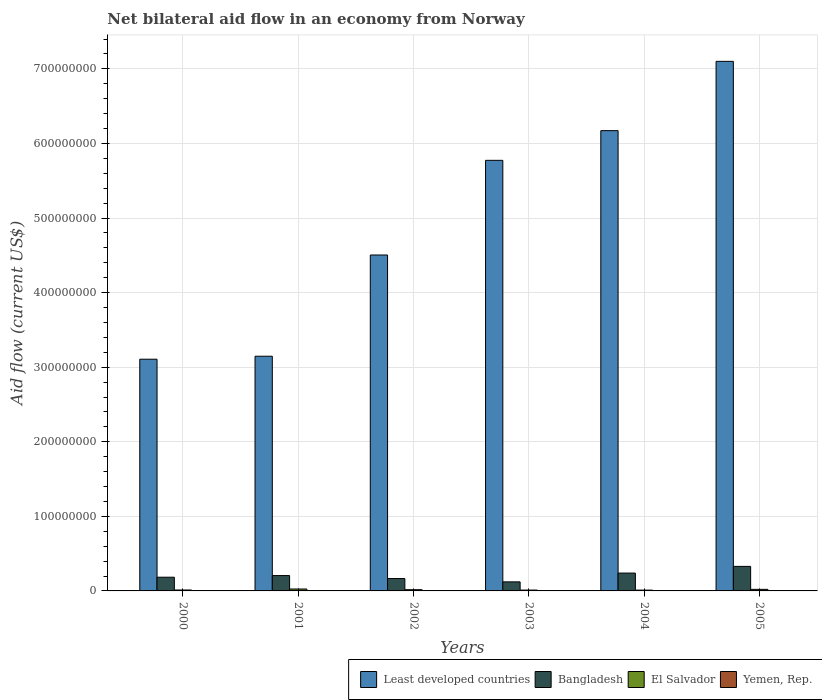Are the number of bars per tick equal to the number of legend labels?
Ensure brevity in your answer.  Yes. How many bars are there on the 3rd tick from the left?
Keep it short and to the point. 4. What is the label of the 3rd group of bars from the left?
Your answer should be compact. 2002. What is the net bilateral aid flow in Bangladesh in 2003?
Ensure brevity in your answer.  1.22e+07. Across all years, what is the maximum net bilateral aid flow in El Salvador?
Your answer should be compact. 2.57e+06. Across all years, what is the minimum net bilateral aid flow in Least developed countries?
Keep it short and to the point. 3.11e+08. What is the total net bilateral aid flow in Yemen, Rep. in the graph?
Provide a succinct answer. 1.70e+06. What is the difference between the net bilateral aid flow in Yemen, Rep. in 2000 and that in 2002?
Give a very brief answer. -2.40e+05. What is the difference between the net bilateral aid flow in El Salvador in 2000 and the net bilateral aid flow in Bangladesh in 2005?
Give a very brief answer. -3.17e+07. What is the average net bilateral aid flow in Least developed countries per year?
Keep it short and to the point. 4.97e+08. In the year 2004, what is the difference between the net bilateral aid flow in Least developed countries and net bilateral aid flow in Yemen, Rep.?
Ensure brevity in your answer.  6.17e+08. In how many years, is the net bilateral aid flow in Bangladesh greater than 360000000 US$?
Make the answer very short. 0. What is the ratio of the net bilateral aid flow in Least developed countries in 2004 to that in 2005?
Your answer should be very brief. 0.87. What is the difference between the highest and the second highest net bilateral aid flow in Least developed countries?
Ensure brevity in your answer.  9.29e+07. What is the difference between the highest and the lowest net bilateral aid flow in Least developed countries?
Keep it short and to the point. 3.99e+08. In how many years, is the net bilateral aid flow in El Salvador greater than the average net bilateral aid flow in El Salvador taken over all years?
Keep it short and to the point. 3. Is the sum of the net bilateral aid flow in El Salvador in 2001 and 2005 greater than the maximum net bilateral aid flow in Bangladesh across all years?
Offer a very short reply. No. Is it the case that in every year, the sum of the net bilateral aid flow in Least developed countries and net bilateral aid flow in Yemen, Rep. is greater than the sum of net bilateral aid flow in Bangladesh and net bilateral aid flow in El Salvador?
Offer a terse response. Yes. What does the 4th bar from the left in 2002 represents?
Give a very brief answer. Yemen, Rep. What does the 1st bar from the right in 2004 represents?
Ensure brevity in your answer.  Yemen, Rep. Is it the case that in every year, the sum of the net bilateral aid flow in El Salvador and net bilateral aid flow in Least developed countries is greater than the net bilateral aid flow in Bangladesh?
Your response must be concise. Yes. How many bars are there?
Offer a terse response. 24. How many years are there in the graph?
Offer a terse response. 6. Does the graph contain any zero values?
Provide a succinct answer. No. Where does the legend appear in the graph?
Provide a short and direct response. Bottom right. What is the title of the graph?
Give a very brief answer. Net bilateral aid flow in an economy from Norway. Does "Low income" appear as one of the legend labels in the graph?
Your answer should be very brief. No. What is the Aid flow (current US$) of Least developed countries in 2000?
Offer a terse response. 3.11e+08. What is the Aid flow (current US$) in Bangladesh in 2000?
Ensure brevity in your answer.  1.84e+07. What is the Aid flow (current US$) of El Salvador in 2000?
Keep it short and to the point. 1.24e+06. What is the Aid flow (current US$) in Least developed countries in 2001?
Offer a terse response. 3.15e+08. What is the Aid flow (current US$) in Bangladesh in 2001?
Your answer should be very brief. 2.06e+07. What is the Aid flow (current US$) in El Salvador in 2001?
Your answer should be very brief. 2.57e+06. What is the Aid flow (current US$) in Yemen, Rep. in 2001?
Your answer should be very brief. 5.00e+04. What is the Aid flow (current US$) of Least developed countries in 2002?
Ensure brevity in your answer.  4.50e+08. What is the Aid flow (current US$) in Bangladesh in 2002?
Provide a short and direct response. 1.66e+07. What is the Aid flow (current US$) of El Salvador in 2002?
Offer a very short reply. 1.67e+06. What is the Aid flow (current US$) in Yemen, Rep. in 2002?
Provide a succinct answer. 3.50e+05. What is the Aid flow (current US$) of Least developed countries in 2003?
Give a very brief answer. 5.77e+08. What is the Aid flow (current US$) in Bangladesh in 2003?
Provide a succinct answer. 1.22e+07. What is the Aid flow (current US$) of El Salvador in 2003?
Ensure brevity in your answer.  1.14e+06. What is the Aid flow (current US$) of Yemen, Rep. in 2003?
Offer a terse response. 3.10e+05. What is the Aid flow (current US$) in Least developed countries in 2004?
Keep it short and to the point. 6.17e+08. What is the Aid flow (current US$) of Bangladesh in 2004?
Your answer should be compact. 2.39e+07. What is the Aid flow (current US$) in El Salvador in 2004?
Offer a terse response. 1.08e+06. What is the Aid flow (current US$) in Least developed countries in 2005?
Offer a terse response. 7.10e+08. What is the Aid flow (current US$) of Bangladesh in 2005?
Offer a very short reply. 3.29e+07. What is the Aid flow (current US$) of El Salvador in 2005?
Provide a short and direct response. 2.11e+06. Across all years, what is the maximum Aid flow (current US$) in Least developed countries?
Provide a short and direct response. 7.10e+08. Across all years, what is the maximum Aid flow (current US$) of Bangladesh?
Provide a short and direct response. 3.29e+07. Across all years, what is the maximum Aid flow (current US$) in El Salvador?
Your answer should be compact. 2.57e+06. Across all years, what is the maximum Aid flow (current US$) in Yemen, Rep.?
Your response must be concise. 4.50e+05. Across all years, what is the minimum Aid flow (current US$) in Least developed countries?
Keep it short and to the point. 3.11e+08. Across all years, what is the minimum Aid flow (current US$) in Bangladesh?
Ensure brevity in your answer.  1.22e+07. Across all years, what is the minimum Aid flow (current US$) in El Salvador?
Your answer should be compact. 1.08e+06. What is the total Aid flow (current US$) of Least developed countries in the graph?
Your answer should be compact. 2.98e+09. What is the total Aid flow (current US$) of Bangladesh in the graph?
Provide a succinct answer. 1.25e+08. What is the total Aid flow (current US$) of El Salvador in the graph?
Your answer should be compact. 9.81e+06. What is the total Aid flow (current US$) of Yemen, Rep. in the graph?
Ensure brevity in your answer.  1.70e+06. What is the difference between the Aid flow (current US$) of Bangladesh in 2000 and that in 2001?
Make the answer very short. -2.20e+06. What is the difference between the Aid flow (current US$) of El Salvador in 2000 and that in 2001?
Provide a succinct answer. -1.33e+06. What is the difference between the Aid flow (current US$) of Yemen, Rep. in 2000 and that in 2001?
Provide a succinct answer. 6.00e+04. What is the difference between the Aid flow (current US$) in Least developed countries in 2000 and that in 2002?
Your response must be concise. -1.40e+08. What is the difference between the Aid flow (current US$) of Bangladesh in 2000 and that in 2002?
Make the answer very short. 1.77e+06. What is the difference between the Aid flow (current US$) in El Salvador in 2000 and that in 2002?
Give a very brief answer. -4.30e+05. What is the difference between the Aid flow (current US$) in Yemen, Rep. in 2000 and that in 2002?
Give a very brief answer. -2.40e+05. What is the difference between the Aid flow (current US$) of Least developed countries in 2000 and that in 2003?
Keep it short and to the point. -2.67e+08. What is the difference between the Aid flow (current US$) of Bangladesh in 2000 and that in 2003?
Offer a terse response. 6.23e+06. What is the difference between the Aid flow (current US$) of El Salvador in 2000 and that in 2003?
Provide a short and direct response. 1.00e+05. What is the difference between the Aid flow (current US$) of Yemen, Rep. in 2000 and that in 2003?
Give a very brief answer. -2.00e+05. What is the difference between the Aid flow (current US$) of Least developed countries in 2000 and that in 2004?
Offer a terse response. -3.06e+08. What is the difference between the Aid flow (current US$) in Bangladesh in 2000 and that in 2004?
Your answer should be compact. -5.56e+06. What is the difference between the Aid flow (current US$) of Yemen, Rep. in 2000 and that in 2004?
Provide a short and direct response. -3.20e+05. What is the difference between the Aid flow (current US$) of Least developed countries in 2000 and that in 2005?
Provide a short and direct response. -3.99e+08. What is the difference between the Aid flow (current US$) in Bangladesh in 2000 and that in 2005?
Provide a succinct answer. -1.45e+07. What is the difference between the Aid flow (current US$) in El Salvador in 2000 and that in 2005?
Offer a terse response. -8.70e+05. What is the difference between the Aid flow (current US$) in Least developed countries in 2001 and that in 2002?
Make the answer very short. -1.36e+08. What is the difference between the Aid flow (current US$) of Bangladesh in 2001 and that in 2002?
Offer a very short reply. 3.97e+06. What is the difference between the Aid flow (current US$) of El Salvador in 2001 and that in 2002?
Keep it short and to the point. 9.00e+05. What is the difference between the Aid flow (current US$) in Least developed countries in 2001 and that in 2003?
Offer a very short reply. -2.63e+08. What is the difference between the Aid flow (current US$) in Bangladesh in 2001 and that in 2003?
Offer a terse response. 8.43e+06. What is the difference between the Aid flow (current US$) of El Salvador in 2001 and that in 2003?
Give a very brief answer. 1.43e+06. What is the difference between the Aid flow (current US$) of Yemen, Rep. in 2001 and that in 2003?
Give a very brief answer. -2.60e+05. What is the difference between the Aid flow (current US$) in Least developed countries in 2001 and that in 2004?
Ensure brevity in your answer.  -3.02e+08. What is the difference between the Aid flow (current US$) of Bangladesh in 2001 and that in 2004?
Ensure brevity in your answer.  -3.36e+06. What is the difference between the Aid flow (current US$) of El Salvador in 2001 and that in 2004?
Offer a very short reply. 1.49e+06. What is the difference between the Aid flow (current US$) in Yemen, Rep. in 2001 and that in 2004?
Offer a terse response. -3.80e+05. What is the difference between the Aid flow (current US$) of Least developed countries in 2001 and that in 2005?
Your response must be concise. -3.95e+08. What is the difference between the Aid flow (current US$) in Bangladesh in 2001 and that in 2005?
Provide a succinct answer. -1.23e+07. What is the difference between the Aid flow (current US$) in Yemen, Rep. in 2001 and that in 2005?
Your response must be concise. -4.00e+05. What is the difference between the Aid flow (current US$) in Least developed countries in 2002 and that in 2003?
Your response must be concise. -1.27e+08. What is the difference between the Aid flow (current US$) in Bangladesh in 2002 and that in 2003?
Ensure brevity in your answer.  4.46e+06. What is the difference between the Aid flow (current US$) of El Salvador in 2002 and that in 2003?
Keep it short and to the point. 5.30e+05. What is the difference between the Aid flow (current US$) in Least developed countries in 2002 and that in 2004?
Provide a short and direct response. -1.67e+08. What is the difference between the Aid flow (current US$) in Bangladesh in 2002 and that in 2004?
Ensure brevity in your answer.  -7.33e+06. What is the difference between the Aid flow (current US$) of El Salvador in 2002 and that in 2004?
Provide a succinct answer. 5.90e+05. What is the difference between the Aid flow (current US$) of Yemen, Rep. in 2002 and that in 2004?
Keep it short and to the point. -8.00e+04. What is the difference between the Aid flow (current US$) in Least developed countries in 2002 and that in 2005?
Ensure brevity in your answer.  -2.60e+08. What is the difference between the Aid flow (current US$) in Bangladesh in 2002 and that in 2005?
Ensure brevity in your answer.  -1.63e+07. What is the difference between the Aid flow (current US$) in El Salvador in 2002 and that in 2005?
Your answer should be compact. -4.40e+05. What is the difference between the Aid flow (current US$) of Yemen, Rep. in 2002 and that in 2005?
Your answer should be very brief. -1.00e+05. What is the difference between the Aid flow (current US$) in Least developed countries in 2003 and that in 2004?
Provide a short and direct response. -3.98e+07. What is the difference between the Aid flow (current US$) of Bangladesh in 2003 and that in 2004?
Make the answer very short. -1.18e+07. What is the difference between the Aid flow (current US$) of El Salvador in 2003 and that in 2004?
Offer a terse response. 6.00e+04. What is the difference between the Aid flow (current US$) of Least developed countries in 2003 and that in 2005?
Provide a short and direct response. -1.33e+08. What is the difference between the Aid flow (current US$) in Bangladesh in 2003 and that in 2005?
Provide a short and direct response. -2.08e+07. What is the difference between the Aid flow (current US$) of El Salvador in 2003 and that in 2005?
Provide a short and direct response. -9.70e+05. What is the difference between the Aid flow (current US$) of Least developed countries in 2004 and that in 2005?
Your response must be concise. -9.29e+07. What is the difference between the Aid flow (current US$) of Bangladesh in 2004 and that in 2005?
Keep it short and to the point. -8.97e+06. What is the difference between the Aid flow (current US$) in El Salvador in 2004 and that in 2005?
Ensure brevity in your answer.  -1.03e+06. What is the difference between the Aid flow (current US$) in Least developed countries in 2000 and the Aid flow (current US$) in Bangladesh in 2001?
Make the answer very short. 2.90e+08. What is the difference between the Aid flow (current US$) in Least developed countries in 2000 and the Aid flow (current US$) in El Salvador in 2001?
Make the answer very short. 3.08e+08. What is the difference between the Aid flow (current US$) in Least developed countries in 2000 and the Aid flow (current US$) in Yemen, Rep. in 2001?
Your answer should be very brief. 3.11e+08. What is the difference between the Aid flow (current US$) of Bangladesh in 2000 and the Aid flow (current US$) of El Salvador in 2001?
Provide a short and direct response. 1.58e+07. What is the difference between the Aid flow (current US$) of Bangladesh in 2000 and the Aid flow (current US$) of Yemen, Rep. in 2001?
Your response must be concise. 1.83e+07. What is the difference between the Aid flow (current US$) of El Salvador in 2000 and the Aid flow (current US$) of Yemen, Rep. in 2001?
Ensure brevity in your answer.  1.19e+06. What is the difference between the Aid flow (current US$) in Least developed countries in 2000 and the Aid flow (current US$) in Bangladesh in 2002?
Provide a short and direct response. 2.94e+08. What is the difference between the Aid flow (current US$) of Least developed countries in 2000 and the Aid flow (current US$) of El Salvador in 2002?
Offer a terse response. 3.09e+08. What is the difference between the Aid flow (current US$) in Least developed countries in 2000 and the Aid flow (current US$) in Yemen, Rep. in 2002?
Keep it short and to the point. 3.10e+08. What is the difference between the Aid flow (current US$) in Bangladesh in 2000 and the Aid flow (current US$) in El Salvador in 2002?
Provide a succinct answer. 1.67e+07. What is the difference between the Aid flow (current US$) in Bangladesh in 2000 and the Aid flow (current US$) in Yemen, Rep. in 2002?
Offer a terse response. 1.80e+07. What is the difference between the Aid flow (current US$) in El Salvador in 2000 and the Aid flow (current US$) in Yemen, Rep. in 2002?
Your answer should be compact. 8.90e+05. What is the difference between the Aid flow (current US$) of Least developed countries in 2000 and the Aid flow (current US$) of Bangladesh in 2003?
Provide a short and direct response. 2.99e+08. What is the difference between the Aid flow (current US$) in Least developed countries in 2000 and the Aid flow (current US$) in El Salvador in 2003?
Keep it short and to the point. 3.10e+08. What is the difference between the Aid flow (current US$) in Least developed countries in 2000 and the Aid flow (current US$) in Yemen, Rep. in 2003?
Give a very brief answer. 3.10e+08. What is the difference between the Aid flow (current US$) in Bangladesh in 2000 and the Aid flow (current US$) in El Salvador in 2003?
Your answer should be compact. 1.72e+07. What is the difference between the Aid flow (current US$) of Bangladesh in 2000 and the Aid flow (current US$) of Yemen, Rep. in 2003?
Ensure brevity in your answer.  1.81e+07. What is the difference between the Aid flow (current US$) in El Salvador in 2000 and the Aid flow (current US$) in Yemen, Rep. in 2003?
Your answer should be compact. 9.30e+05. What is the difference between the Aid flow (current US$) of Least developed countries in 2000 and the Aid flow (current US$) of Bangladesh in 2004?
Give a very brief answer. 2.87e+08. What is the difference between the Aid flow (current US$) of Least developed countries in 2000 and the Aid flow (current US$) of El Salvador in 2004?
Provide a succinct answer. 3.10e+08. What is the difference between the Aid flow (current US$) of Least developed countries in 2000 and the Aid flow (current US$) of Yemen, Rep. in 2004?
Ensure brevity in your answer.  3.10e+08. What is the difference between the Aid flow (current US$) in Bangladesh in 2000 and the Aid flow (current US$) in El Salvador in 2004?
Provide a short and direct response. 1.73e+07. What is the difference between the Aid flow (current US$) of Bangladesh in 2000 and the Aid flow (current US$) of Yemen, Rep. in 2004?
Offer a terse response. 1.80e+07. What is the difference between the Aid flow (current US$) of El Salvador in 2000 and the Aid flow (current US$) of Yemen, Rep. in 2004?
Your response must be concise. 8.10e+05. What is the difference between the Aid flow (current US$) in Least developed countries in 2000 and the Aid flow (current US$) in Bangladesh in 2005?
Make the answer very short. 2.78e+08. What is the difference between the Aid flow (current US$) in Least developed countries in 2000 and the Aid flow (current US$) in El Salvador in 2005?
Give a very brief answer. 3.09e+08. What is the difference between the Aid flow (current US$) of Least developed countries in 2000 and the Aid flow (current US$) of Yemen, Rep. in 2005?
Ensure brevity in your answer.  3.10e+08. What is the difference between the Aid flow (current US$) in Bangladesh in 2000 and the Aid flow (current US$) in El Salvador in 2005?
Your response must be concise. 1.63e+07. What is the difference between the Aid flow (current US$) in Bangladesh in 2000 and the Aid flow (current US$) in Yemen, Rep. in 2005?
Provide a short and direct response. 1.79e+07. What is the difference between the Aid flow (current US$) of El Salvador in 2000 and the Aid flow (current US$) of Yemen, Rep. in 2005?
Ensure brevity in your answer.  7.90e+05. What is the difference between the Aid flow (current US$) in Least developed countries in 2001 and the Aid flow (current US$) in Bangladesh in 2002?
Ensure brevity in your answer.  2.98e+08. What is the difference between the Aid flow (current US$) in Least developed countries in 2001 and the Aid flow (current US$) in El Salvador in 2002?
Keep it short and to the point. 3.13e+08. What is the difference between the Aid flow (current US$) in Least developed countries in 2001 and the Aid flow (current US$) in Yemen, Rep. in 2002?
Provide a succinct answer. 3.14e+08. What is the difference between the Aid flow (current US$) of Bangladesh in 2001 and the Aid flow (current US$) of El Salvador in 2002?
Your response must be concise. 1.89e+07. What is the difference between the Aid flow (current US$) of Bangladesh in 2001 and the Aid flow (current US$) of Yemen, Rep. in 2002?
Offer a terse response. 2.02e+07. What is the difference between the Aid flow (current US$) of El Salvador in 2001 and the Aid flow (current US$) of Yemen, Rep. in 2002?
Offer a terse response. 2.22e+06. What is the difference between the Aid flow (current US$) of Least developed countries in 2001 and the Aid flow (current US$) of Bangladesh in 2003?
Keep it short and to the point. 3.03e+08. What is the difference between the Aid flow (current US$) of Least developed countries in 2001 and the Aid flow (current US$) of El Salvador in 2003?
Your answer should be compact. 3.14e+08. What is the difference between the Aid flow (current US$) of Least developed countries in 2001 and the Aid flow (current US$) of Yemen, Rep. in 2003?
Keep it short and to the point. 3.14e+08. What is the difference between the Aid flow (current US$) of Bangladesh in 2001 and the Aid flow (current US$) of El Salvador in 2003?
Keep it short and to the point. 1.94e+07. What is the difference between the Aid flow (current US$) of Bangladesh in 2001 and the Aid flow (current US$) of Yemen, Rep. in 2003?
Offer a very short reply. 2.03e+07. What is the difference between the Aid flow (current US$) of El Salvador in 2001 and the Aid flow (current US$) of Yemen, Rep. in 2003?
Your answer should be compact. 2.26e+06. What is the difference between the Aid flow (current US$) of Least developed countries in 2001 and the Aid flow (current US$) of Bangladesh in 2004?
Give a very brief answer. 2.91e+08. What is the difference between the Aid flow (current US$) of Least developed countries in 2001 and the Aid flow (current US$) of El Salvador in 2004?
Ensure brevity in your answer.  3.14e+08. What is the difference between the Aid flow (current US$) in Least developed countries in 2001 and the Aid flow (current US$) in Yemen, Rep. in 2004?
Give a very brief answer. 3.14e+08. What is the difference between the Aid flow (current US$) of Bangladesh in 2001 and the Aid flow (current US$) of El Salvador in 2004?
Make the answer very short. 1.95e+07. What is the difference between the Aid flow (current US$) of Bangladesh in 2001 and the Aid flow (current US$) of Yemen, Rep. in 2004?
Make the answer very short. 2.02e+07. What is the difference between the Aid flow (current US$) in El Salvador in 2001 and the Aid flow (current US$) in Yemen, Rep. in 2004?
Your answer should be very brief. 2.14e+06. What is the difference between the Aid flow (current US$) in Least developed countries in 2001 and the Aid flow (current US$) in Bangladesh in 2005?
Your answer should be compact. 2.82e+08. What is the difference between the Aid flow (current US$) in Least developed countries in 2001 and the Aid flow (current US$) in El Salvador in 2005?
Offer a terse response. 3.13e+08. What is the difference between the Aid flow (current US$) in Least developed countries in 2001 and the Aid flow (current US$) in Yemen, Rep. in 2005?
Make the answer very short. 3.14e+08. What is the difference between the Aid flow (current US$) of Bangladesh in 2001 and the Aid flow (current US$) of El Salvador in 2005?
Offer a terse response. 1.85e+07. What is the difference between the Aid flow (current US$) in Bangladesh in 2001 and the Aid flow (current US$) in Yemen, Rep. in 2005?
Make the answer very short. 2.01e+07. What is the difference between the Aid flow (current US$) of El Salvador in 2001 and the Aid flow (current US$) of Yemen, Rep. in 2005?
Your response must be concise. 2.12e+06. What is the difference between the Aid flow (current US$) in Least developed countries in 2002 and the Aid flow (current US$) in Bangladesh in 2003?
Keep it short and to the point. 4.38e+08. What is the difference between the Aid flow (current US$) in Least developed countries in 2002 and the Aid flow (current US$) in El Salvador in 2003?
Your response must be concise. 4.49e+08. What is the difference between the Aid flow (current US$) of Least developed countries in 2002 and the Aid flow (current US$) of Yemen, Rep. in 2003?
Offer a terse response. 4.50e+08. What is the difference between the Aid flow (current US$) in Bangladesh in 2002 and the Aid flow (current US$) in El Salvador in 2003?
Ensure brevity in your answer.  1.55e+07. What is the difference between the Aid flow (current US$) of Bangladesh in 2002 and the Aid flow (current US$) of Yemen, Rep. in 2003?
Make the answer very short. 1.63e+07. What is the difference between the Aid flow (current US$) of El Salvador in 2002 and the Aid flow (current US$) of Yemen, Rep. in 2003?
Make the answer very short. 1.36e+06. What is the difference between the Aid flow (current US$) of Least developed countries in 2002 and the Aid flow (current US$) of Bangladesh in 2004?
Provide a succinct answer. 4.27e+08. What is the difference between the Aid flow (current US$) in Least developed countries in 2002 and the Aid flow (current US$) in El Salvador in 2004?
Your response must be concise. 4.49e+08. What is the difference between the Aid flow (current US$) of Least developed countries in 2002 and the Aid flow (current US$) of Yemen, Rep. in 2004?
Ensure brevity in your answer.  4.50e+08. What is the difference between the Aid flow (current US$) of Bangladesh in 2002 and the Aid flow (current US$) of El Salvador in 2004?
Your answer should be compact. 1.55e+07. What is the difference between the Aid flow (current US$) of Bangladesh in 2002 and the Aid flow (current US$) of Yemen, Rep. in 2004?
Give a very brief answer. 1.62e+07. What is the difference between the Aid flow (current US$) of El Salvador in 2002 and the Aid flow (current US$) of Yemen, Rep. in 2004?
Provide a short and direct response. 1.24e+06. What is the difference between the Aid flow (current US$) of Least developed countries in 2002 and the Aid flow (current US$) of Bangladesh in 2005?
Your response must be concise. 4.18e+08. What is the difference between the Aid flow (current US$) in Least developed countries in 2002 and the Aid flow (current US$) in El Salvador in 2005?
Give a very brief answer. 4.48e+08. What is the difference between the Aid flow (current US$) of Least developed countries in 2002 and the Aid flow (current US$) of Yemen, Rep. in 2005?
Provide a succinct answer. 4.50e+08. What is the difference between the Aid flow (current US$) in Bangladesh in 2002 and the Aid flow (current US$) in El Salvador in 2005?
Give a very brief answer. 1.45e+07. What is the difference between the Aid flow (current US$) in Bangladesh in 2002 and the Aid flow (current US$) in Yemen, Rep. in 2005?
Provide a short and direct response. 1.62e+07. What is the difference between the Aid flow (current US$) of El Salvador in 2002 and the Aid flow (current US$) of Yemen, Rep. in 2005?
Provide a succinct answer. 1.22e+06. What is the difference between the Aid flow (current US$) of Least developed countries in 2003 and the Aid flow (current US$) of Bangladesh in 2004?
Make the answer very short. 5.53e+08. What is the difference between the Aid flow (current US$) in Least developed countries in 2003 and the Aid flow (current US$) in El Salvador in 2004?
Keep it short and to the point. 5.76e+08. What is the difference between the Aid flow (current US$) of Least developed countries in 2003 and the Aid flow (current US$) of Yemen, Rep. in 2004?
Offer a very short reply. 5.77e+08. What is the difference between the Aid flow (current US$) in Bangladesh in 2003 and the Aid flow (current US$) in El Salvador in 2004?
Your response must be concise. 1.11e+07. What is the difference between the Aid flow (current US$) of Bangladesh in 2003 and the Aid flow (current US$) of Yemen, Rep. in 2004?
Give a very brief answer. 1.17e+07. What is the difference between the Aid flow (current US$) of El Salvador in 2003 and the Aid flow (current US$) of Yemen, Rep. in 2004?
Provide a succinct answer. 7.10e+05. What is the difference between the Aid flow (current US$) of Least developed countries in 2003 and the Aid flow (current US$) of Bangladesh in 2005?
Your response must be concise. 5.44e+08. What is the difference between the Aid flow (current US$) of Least developed countries in 2003 and the Aid flow (current US$) of El Salvador in 2005?
Your answer should be very brief. 5.75e+08. What is the difference between the Aid flow (current US$) in Least developed countries in 2003 and the Aid flow (current US$) in Yemen, Rep. in 2005?
Offer a very short reply. 5.77e+08. What is the difference between the Aid flow (current US$) in Bangladesh in 2003 and the Aid flow (current US$) in El Salvador in 2005?
Your answer should be very brief. 1.00e+07. What is the difference between the Aid flow (current US$) in Bangladesh in 2003 and the Aid flow (current US$) in Yemen, Rep. in 2005?
Give a very brief answer. 1.17e+07. What is the difference between the Aid flow (current US$) of El Salvador in 2003 and the Aid flow (current US$) of Yemen, Rep. in 2005?
Your response must be concise. 6.90e+05. What is the difference between the Aid flow (current US$) of Least developed countries in 2004 and the Aid flow (current US$) of Bangladesh in 2005?
Make the answer very short. 5.84e+08. What is the difference between the Aid flow (current US$) of Least developed countries in 2004 and the Aid flow (current US$) of El Salvador in 2005?
Make the answer very short. 6.15e+08. What is the difference between the Aid flow (current US$) of Least developed countries in 2004 and the Aid flow (current US$) of Yemen, Rep. in 2005?
Your answer should be very brief. 6.17e+08. What is the difference between the Aid flow (current US$) of Bangladesh in 2004 and the Aid flow (current US$) of El Salvador in 2005?
Your answer should be very brief. 2.18e+07. What is the difference between the Aid flow (current US$) in Bangladesh in 2004 and the Aid flow (current US$) in Yemen, Rep. in 2005?
Offer a very short reply. 2.35e+07. What is the difference between the Aid flow (current US$) in El Salvador in 2004 and the Aid flow (current US$) in Yemen, Rep. in 2005?
Your response must be concise. 6.30e+05. What is the average Aid flow (current US$) of Least developed countries per year?
Keep it short and to the point. 4.97e+08. What is the average Aid flow (current US$) in Bangladesh per year?
Offer a very short reply. 2.08e+07. What is the average Aid flow (current US$) of El Salvador per year?
Provide a short and direct response. 1.64e+06. What is the average Aid flow (current US$) of Yemen, Rep. per year?
Make the answer very short. 2.83e+05. In the year 2000, what is the difference between the Aid flow (current US$) of Least developed countries and Aid flow (current US$) of Bangladesh?
Provide a succinct answer. 2.92e+08. In the year 2000, what is the difference between the Aid flow (current US$) in Least developed countries and Aid flow (current US$) in El Salvador?
Make the answer very short. 3.09e+08. In the year 2000, what is the difference between the Aid flow (current US$) in Least developed countries and Aid flow (current US$) in Yemen, Rep.?
Provide a short and direct response. 3.11e+08. In the year 2000, what is the difference between the Aid flow (current US$) of Bangladesh and Aid flow (current US$) of El Salvador?
Provide a succinct answer. 1.71e+07. In the year 2000, what is the difference between the Aid flow (current US$) in Bangladesh and Aid flow (current US$) in Yemen, Rep.?
Ensure brevity in your answer.  1.83e+07. In the year 2000, what is the difference between the Aid flow (current US$) in El Salvador and Aid flow (current US$) in Yemen, Rep.?
Keep it short and to the point. 1.13e+06. In the year 2001, what is the difference between the Aid flow (current US$) in Least developed countries and Aid flow (current US$) in Bangladesh?
Your answer should be compact. 2.94e+08. In the year 2001, what is the difference between the Aid flow (current US$) in Least developed countries and Aid flow (current US$) in El Salvador?
Your answer should be very brief. 3.12e+08. In the year 2001, what is the difference between the Aid flow (current US$) of Least developed countries and Aid flow (current US$) of Yemen, Rep.?
Your answer should be compact. 3.15e+08. In the year 2001, what is the difference between the Aid flow (current US$) in Bangladesh and Aid flow (current US$) in El Salvador?
Ensure brevity in your answer.  1.80e+07. In the year 2001, what is the difference between the Aid flow (current US$) in Bangladesh and Aid flow (current US$) in Yemen, Rep.?
Offer a terse response. 2.05e+07. In the year 2001, what is the difference between the Aid flow (current US$) of El Salvador and Aid flow (current US$) of Yemen, Rep.?
Your response must be concise. 2.52e+06. In the year 2002, what is the difference between the Aid flow (current US$) in Least developed countries and Aid flow (current US$) in Bangladesh?
Keep it short and to the point. 4.34e+08. In the year 2002, what is the difference between the Aid flow (current US$) in Least developed countries and Aid flow (current US$) in El Salvador?
Provide a succinct answer. 4.49e+08. In the year 2002, what is the difference between the Aid flow (current US$) of Least developed countries and Aid flow (current US$) of Yemen, Rep.?
Offer a terse response. 4.50e+08. In the year 2002, what is the difference between the Aid flow (current US$) in Bangladesh and Aid flow (current US$) in El Salvador?
Provide a short and direct response. 1.49e+07. In the year 2002, what is the difference between the Aid flow (current US$) of Bangladesh and Aid flow (current US$) of Yemen, Rep.?
Your answer should be very brief. 1.63e+07. In the year 2002, what is the difference between the Aid flow (current US$) of El Salvador and Aid flow (current US$) of Yemen, Rep.?
Your answer should be compact. 1.32e+06. In the year 2003, what is the difference between the Aid flow (current US$) of Least developed countries and Aid flow (current US$) of Bangladesh?
Offer a terse response. 5.65e+08. In the year 2003, what is the difference between the Aid flow (current US$) of Least developed countries and Aid flow (current US$) of El Salvador?
Keep it short and to the point. 5.76e+08. In the year 2003, what is the difference between the Aid flow (current US$) of Least developed countries and Aid flow (current US$) of Yemen, Rep.?
Your response must be concise. 5.77e+08. In the year 2003, what is the difference between the Aid flow (current US$) in Bangladesh and Aid flow (current US$) in El Salvador?
Ensure brevity in your answer.  1.10e+07. In the year 2003, what is the difference between the Aid flow (current US$) of Bangladesh and Aid flow (current US$) of Yemen, Rep.?
Your answer should be compact. 1.18e+07. In the year 2003, what is the difference between the Aid flow (current US$) in El Salvador and Aid flow (current US$) in Yemen, Rep.?
Provide a succinct answer. 8.30e+05. In the year 2004, what is the difference between the Aid flow (current US$) of Least developed countries and Aid flow (current US$) of Bangladesh?
Ensure brevity in your answer.  5.93e+08. In the year 2004, what is the difference between the Aid flow (current US$) in Least developed countries and Aid flow (current US$) in El Salvador?
Keep it short and to the point. 6.16e+08. In the year 2004, what is the difference between the Aid flow (current US$) in Least developed countries and Aid flow (current US$) in Yemen, Rep.?
Provide a succinct answer. 6.17e+08. In the year 2004, what is the difference between the Aid flow (current US$) in Bangladesh and Aid flow (current US$) in El Salvador?
Give a very brief answer. 2.29e+07. In the year 2004, what is the difference between the Aid flow (current US$) of Bangladesh and Aid flow (current US$) of Yemen, Rep.?
Give a very brief answer. 2.35e+07. In the year 2004, what is the difference between the Aid flow (current US$) of El Salvador and Aid flow (current US$) of Yemen, Rep.?
Offer a very short reply. 6.50e+05. In the year 2005, what is the difference between the Aid flow (current US$) of Least developed countries and Aid flow (current US$) of Bangladesh?
Offer a very short reply. 6.77e+08. In the year 2005, what is the difference between the Aid flow (current US$) in Least developed countries and Aid flow (current US$) in El Salvador?
Provide a short and direct response. 7.08e+08. In the year 2005, what is the difference between the Aid flow (current US$) of Least developed countries and Aid flow (current US$) of Yemen, Rep.?
Your response must be concise. 7.10e+08. In the year 2005, what is the difference between the Aid flow (current US$) of Bangladesh and Aid flow (current US$) of El Salvador?
Keep it short and to the point. 3.08e+07. In the year 2005, what is the difference between the Aid flow (current US$) of Bangladesh and Aid flow (current US$) of Yemen, Rep.?
Make the answer very short. 3.25e+07. In the year 2005, what is the difference between the Aid flow (current US$) in El Salvador and Aid flow (current US$) in Yemen, Rep.?
Offer a terse response. 1.66e+06. What is the ratio of the Aid flow (current US$) in Least developed countries in 2000 to that in 2001?
Make the answer very short. 0.99. What is the ratio of the Aid flow (current US$) in Bangladesh in 2000 to that in 2001?
Your answer should be very brief. 0.89. What is the ratio of the Aid flow (current US$) in El Salvador in 2000 to that in 2001?
Provide a succinct answer. 0.48. What is the ratio of the Aid flow (current US$) in Least developed countries in 2000 to that in 2002?
Provide a succinct answer. 0.69. What is the ratio of the Aid flow (current US$) in Bangladesh in 2000 to that in 2002?
Keep it short and to the point. 1.11. What is the ratio of the Aid flow (current US$) in El Salvador in 2000 to that in 2002?
Your answer should be compact. 0.74. What is the ratio of the Aid flow (current US$) of Yemen, Rep. in 2000 to that in 2002?
Your answer should be very brief. 0.31. What is the ratio of the Aid flow (current US$) in Least developed countries in 2000 to that in 2003?
Make the answer very short. 0.54. What is the ratio of the Aid flow (current US$) in Bangladesh in 2000 to that in 2003?
Provide a succinct answer. 1.51. What is the ratio of the Aid flow (current US$) of El Salvador in 2000 to that in 2003?
Your answer should be compact. 1.09. What is the ratio of the Aid flow (current US$) of Yemen, Rep. in 2000 to that in 2003?
Keep it short and to the point. 0.35. What is the ratio of the Aid flow (current US$) in Least developed countries in 2000 to that in 2004?
Your answer should be compact. 0.5. What is the ratio of the Aid flow (current US$) in Bangladesh in 2000 to that in 2004?
Ensure brevity in your answer.  0.77. What is the ratio of the Aid flow (current US$) of El Salvador in 2000 to that in 2004?
Give a very brief answer. 1.15. What is the ratio of the Aid flow (current US$) of Yemen, Rep. in 2000 to that in 2004?
Offer a terse response. 0.26. What is the ratio of the Aid flow (current US$) of Least developed countries in 2000 to that in 2005?
Provide a short and direct response. 0.44. What is the ratio of the Aid flow (current US$) in Bangladesh in 2000 to that in 2005?
Give a very brief answer. 0.56. What is the ratio of the Aid flow (current US$) of El Salvador in 2000 to that in 2005?
Provide a succinct answer. 0.59. What is the ratio of the Aid flow (current US$) in Yemen, Rep. in 2000 to that in 2005?
Make the answer very short. 0.24. What is the ratio of the Aid flow (current US$) in Least developed countries in 2001 to that in 2002?
Ensure brevity in your answer.  0.7. What is the ratio of the Aid flow (current US$) of Bangladesh in 2001 to that in 2002?
Provide a succinct answer. 1.24. What is the ratio of the Aid flow (current US$) of El Salvador in 2001 to that in 2002?
Offer a very short reply. 1.54. What is the ratio of the Aid flow (current US$) of Yemen, Rep. in 2001 to that in 2002?
Your response must be concise. 0.14. What is the ratio of the Aid flow (current US$) in Least developed countries in 2001 to that in 2003?
Offer a very short reply. 0.55. What is the ratio of the Aid flow (current US$) of Bangladesh in 2001 to that in 2003?
Your answer should be very brief. 1.69. What is the ratio of the Aid flow (current US$) in El Salvador in 2001 to that in 2003?
Offer a terse response. 2.25. What is the ratio of the Aid flow (current US$) of Yemen, Rep. in 2001 to that in 2003?
Make the answer very short. 0.16. What is the ratio of the Aid flow (current US$) in Least developed countries in 2001 to that in 2004?
Your response must be concise. 0.51. What is the ratio of the Aid flow (current US$) of Bangladesh in 2001 to that in 2004?
Your answer should be compact. 0.86. What is the ratio of the Aid flow (current US$) in El Salvador in 2001 to that in 2004?
Make the answer very short. 2.38. What is the ratio of the Aid flow (current US$) in Yemen, Rep. in 2001 to that in 2004?
Keep it short and to the point. 0.12. What is the ratio of the Aid flow (current US$) in Least developed countries in 2001 to that in 2005?
Offer a very short reply. 0.44. What is the ratio of the Aid flow (current US$) in Bangladesh in 2001 to that in 2005?
Your response must be concise. 0.63. What is the ratio of the Aid flow (current US$) of El Salvador in 2001 to that in 2005?
Your answer should be compact. 1.22. What is the ratio of the Aid flow (current US$) of Least developed countries in 2002 to that in 2003?
Provide a short and direct response. 0.78. What is the ratio of the Aid flow (current US$) in Bangladesh in 2002 to that in 2003?
Provide a short and direct response. 1.37. What is the ratio of the Aid flow (current US$) of El Salvador in 2002 to that in 2003?
Provide a short and direct response. 1.46. What is the ratio of the Aid flow (current US$) in Yemen, Rep. in 2002 to that in 2003?
Provide a succinct answer. 1.13. What is the ratio of the Aid flow (current US$) in Least developed countries in 2002 to that in 2004?
Offer a very short reply. 0.73. What is the ratio of the Aid flow (current US$) in Bangladesh in 2002 to that in 2004?
Ensure brevity in your answer.  0.69. What is the ratio of the Aid flow (current US$) of El Salvador in 2002 to that in 2004?
Give a very brief answer. 1.55. What is the ratio of the Aid flow (current US$) of Yemen, Rep. in 2002 to that in 2004?
Provide a short and direct response. 0.81. What is the ratio of the Aid flow (current US$) in Least developed countries in 2002 to that in 2005?
Keep it short and to the point. 0.63. What is the ratio of the Aid flow (current US$) of Bangladesh in 2002 to that in 2005?
Make the answer very short. 0.5. What is the ratio of the Aid flow (current US$) of El Salvador in 2002 to that in 2005?
Your response must be concise. 0.79. What is the ratio of the Aid flow (current US$) of Yemen, Rep. in 2002 to that in 2005?
Ensure brevity in your answer.  0.78. What is the ratio of the Aid flow (current US$) of Least developed countries in 2003 to that in 2004?
Your answer should be very brief. 0.94. What is the ratio of the Aid flow (current US$) of Bangladesh in 2003 to that in 2004?
Your answer should be compact. 0.51. What is the ratio of the Aid flow (current US$) of El Salvador in 2003 to that in 2004?
Offer a terse response. 1.06. What is the ratio of the Aid flow (current US$) in Yemen, Rep. in 2003 to that in 2004?
Keep it short and to the point. 0.72. What is the ratio of the Aid flow (current US$) in Least developed countries in 2003 to that in 2005?
Ensure brevity in your answer.  0.81. What is the ratio of the Aid flow (current US$) in Bangladesh in 2003 to that in 2005?
Provide a succinct answer. 0.37. What is the ratio of the Aid flow (current US$) of El Salvador in 2003 to that in 2005?
Your response must be concise. 0.54. What is the ratio of the Aid flow (current US$) of Yemen, Rep. in 2003 to that in 2005?
Offer a terse response. 0.69. What is the ratio of the Aid flow (current US$) of Least developed countries in 2004 to that in 2005?
Your answer should be compact. 0.87. What is the ratio of the Aid flow (current US$) in Bangladesh in 2004 to that in 2005?
Ensure brevity in your answer.  0.73. What is the ratio of the Aid flow (current US$) of El Salvador in 2004 to that in 2005?
Provide a succinct answer. 0.51. What is the ratio of the Aid flow (current US$) of Yemen, Rep. in 2004 to that in 2005?
Provide a short and direct response. 0.96. What is the difference between the highest and the second highest Aid flow (current US$) of Least developed countries?
Ensure brevity in your answer.  9.29e+07. What is the difference between the highest and the second highest Aid flow (current US$) of Bangladesh?
Make the answer very short. 8.97e+06. What is the difference between the highest and the second highest Aid flow (current US$) of El Salvador?
Keep it short and to the point. 4.60e+05. What is the difference between the highest and the second highest Aid flow (current US$) of Yemen, Rep.?
Your answer should be very brief. 2.00e+04. What is the difference between the highest and the lowest Aid flow (current US$) in Least developed countries?
Offer a terse response. 3.99e+08. What is the difference between the highest and the lowest Aid flow (current US$) of Bangladesh?
Offer a very short reply. 2.08e+07. What is the difference between the highest and the lowest Aid flow (current US$) in El Salvador?
Provide a short and direct response. 1.49e+06. What is the difference between the highest and the lowest Aid flow (current US$) in Yemen, Rep.?
Make the answer very short. 4.00e+05. 